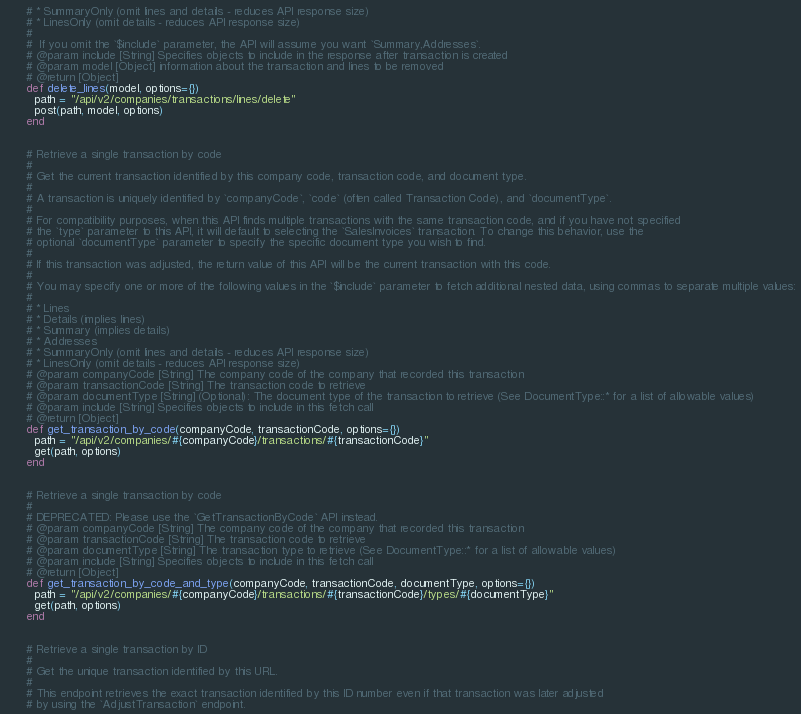<code> <loc_0><loc_0><loc_500><loc_500><_Ruby_>      # * SummaryOnly (omit lines and details - reduces API response size)
      # * LinesOnly (omit details - reduces API response size)
      #
      #  If you omit the `$include` parameter, the API will assume you want `Summary,Addresses`.
      # @param include [String] Specifies objects to include in the response after transaction is created
      # @param model [Object] information about the transaction and lines to be removed
      # @return [Object]
      def delete_lines(model, options={})
        path = "/api/v2/companies/transactions/lines/delete"
        post(path, model, options)
      end


      # Retrieve a single transaction by code
      #
      # Get the current transaction identified by this company code, transaction code, and document type.
      #
      # A transaction is uniquely identified by `companyCode`, `code` (often called Transaction Code), and `documentType`.
      #
      # For compatibility purposes, when this API finds multiple transactions with the same transaction code, and if you have not specified
      # the `type` parameter to this API, it will default to selecting the `SalesInvoices` transaction. To change this behavior, use the
      # optional `documentType` parameter to specify the specific document type you wish to find.
      #
      # If this transaction was adjusted, the return value of this API will be the current transaction with this code.
      #
      # You may specify one or more of the following values in the `$include` parameter to fetch additional nested data, using commas to separate multiple values:
      #
      # * Lines
      # * Details (implies lines)
      # * Summary (implies details)
      # * Addresses
      # * SummaryOnly (omit lines and details - reduces API response size)
      # * LinesOnly (omit details - reduces API response size)
      # @param companyCode [String] The company code of the company that recorded this transaction
      # @param transactionCode [String] The transaction code to retrieve
      # @param documentType [String] (Optional): The document type of the transaction to retrieve (See DocumentType::* for a list of allowable values)
      # @param include [String] Specifies objects to include in this fetch call
      # @return [Object]
      def get_transaction_by_code(companyCode, transactionCode, options={})
        path = "/api/v2/companies/#{companyCode}/transactions/#{transactionCode}"
        get(path, options)
      end


      # Retrieve a single transaction by code
      #
      # DEPRECATED: Please use the `GetTransactionByCode` API instead.
      # @param companyCode [String] The company code of the company that recorded this transaction
      # @param transactionCode [String] The transaction code to retrieve
      # @param documentType [String] The transaction type to retrieve (See DocumentType::* for a list of allowable values)
      # @param include [String] Specifies objects to include in this fetch call
      # @return [Object]
      def get_transaction_by_code_and_type(companyCode, transactionCode, documentType, options={})
        path = "/api/v2/companies/#{companyCode}/transactions/#{transactionCode}/types/#{documentType}"
        get(path, options)
      end


      # Retrieve a single transaction by ID
      #
      # Get the unique transaction identified by this URL.
      #
      # This endpoint retrieves the exact transaction identified by this ID number even if that transaction was later adjusted
      # by using the `AdjustTransaction` endpoint.</code> 